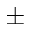Convert formula to latex. <formula><loc_0><loc_0><loc_500><loc_500>\pm</formula> 